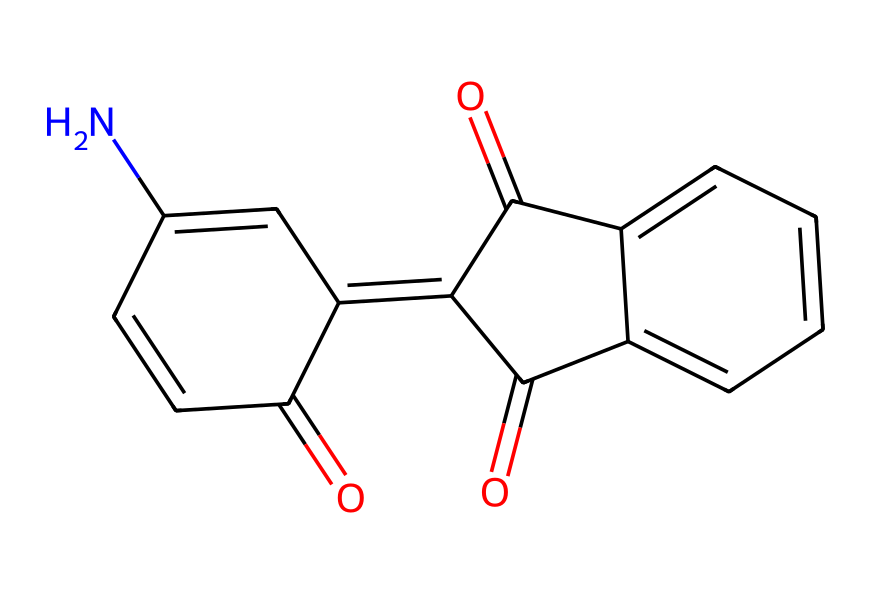What is the name of this dye? The provided SMILES structure corresponds to indigo, a widely known blue dye that has been used historically in textiles and is derived from indole.
Answer: indigo How many carbon atoms are in the structure? By analyzing the SMILES representation, we can count the number of carbon atoms represented, which totals to 14 carbon atoms in the structure.
Answer: 14 What functional groups are present in indigo dye? The molecule contains carbonyl (C=O) functional groups indicated by the presence of 'O=' in the SMILES, particularly two pairs, defining the two amide groups typical for indigo.
Answer: carbonyl What is the total number of rings in the structure? The structure shows that there are two fused aromatic rings represented in the SMILES, so we identify there are 2 interconnected rings forming the indigo structure.
Answer: 2 Is this dye a natural or synthetic compound? Indigo has both natural and synthetic forms, but historically it comes from natural sources like the indigo plant, whereas it can also be manufactured synthetically. Thus, it is classified as a natural dye.
Answer: natural What color does indigo dye produce? Indigo dye is known for producing a deep blue color, which is characteristic and widely recognized in various fabric applications.
Answer: blue What is the significance of the nitrogen atom in the structure? The nitrogen atom in the structure contributes to the stability and solubility properties of indigo dye, and it also plays a role in the dye’s interactions with fibers during the dyeing process.
Answer: stability 